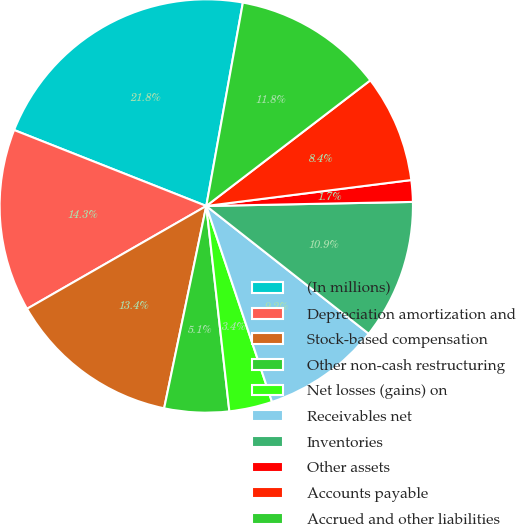Convert chart to OTSL. <chart><loc_0><loc_0><loc_500><loc_500><pie_chart><fcel>(In millions)<fcel>Depreciation amortization and<fcel>Stock-based compensation<fcel>Other non-cash restructuring<fcel>Net losses (gains) on<fcel>Receivables net<fcel>Inventories<fcel>Other assets<fcel>Accounts payable<fcel>Accrued and other liabilities<nl><fcel>21.84%<fcel>14.28%<fcel>13.44%<fcel>5.05%<fcel>3.37%<fcel>9.24%<fcel>10.92%<fcel>1.69%<fcel>8.4%<fcel>11.76%<nl></chart> 